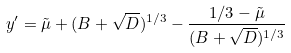<formula> <loc_0><loc_0><loc_500><loc_500>y ^ { \prime } = \tilde { \mu } + ( B + \sqrt { D } ) ^ { 1 / 3 } - \frac { 1 / 3 - \tilde { \mu } } { ( B + \sqrt { D } ) ^ { 1 / 3 } }</formula> 